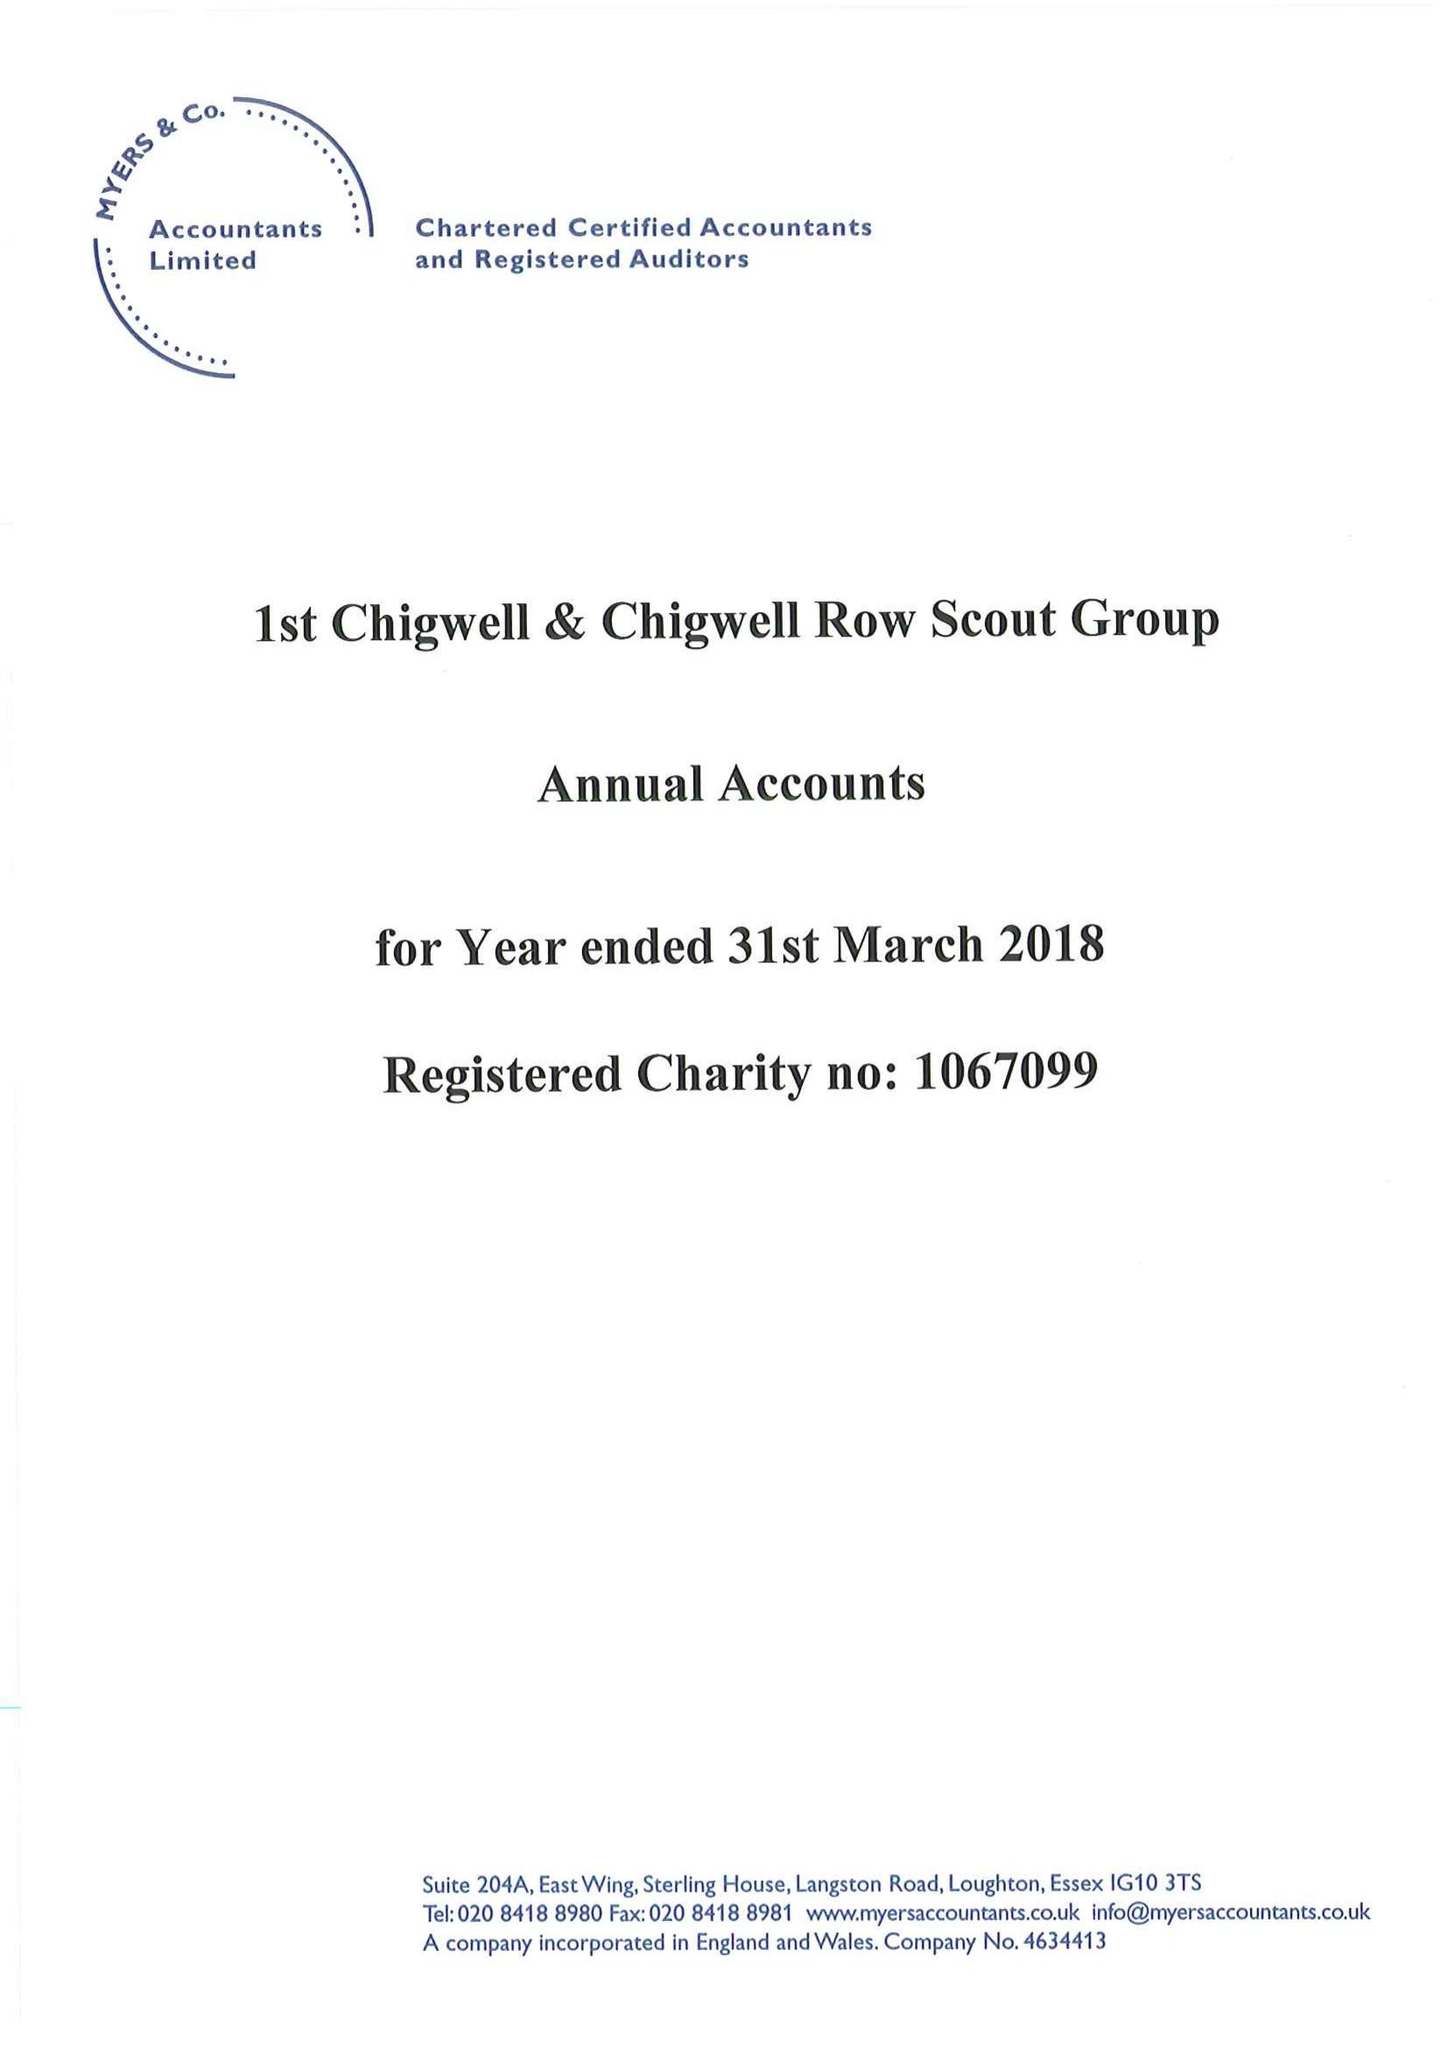What is the value for the address__street_line?
Answer the question using a single word or phrase. None 